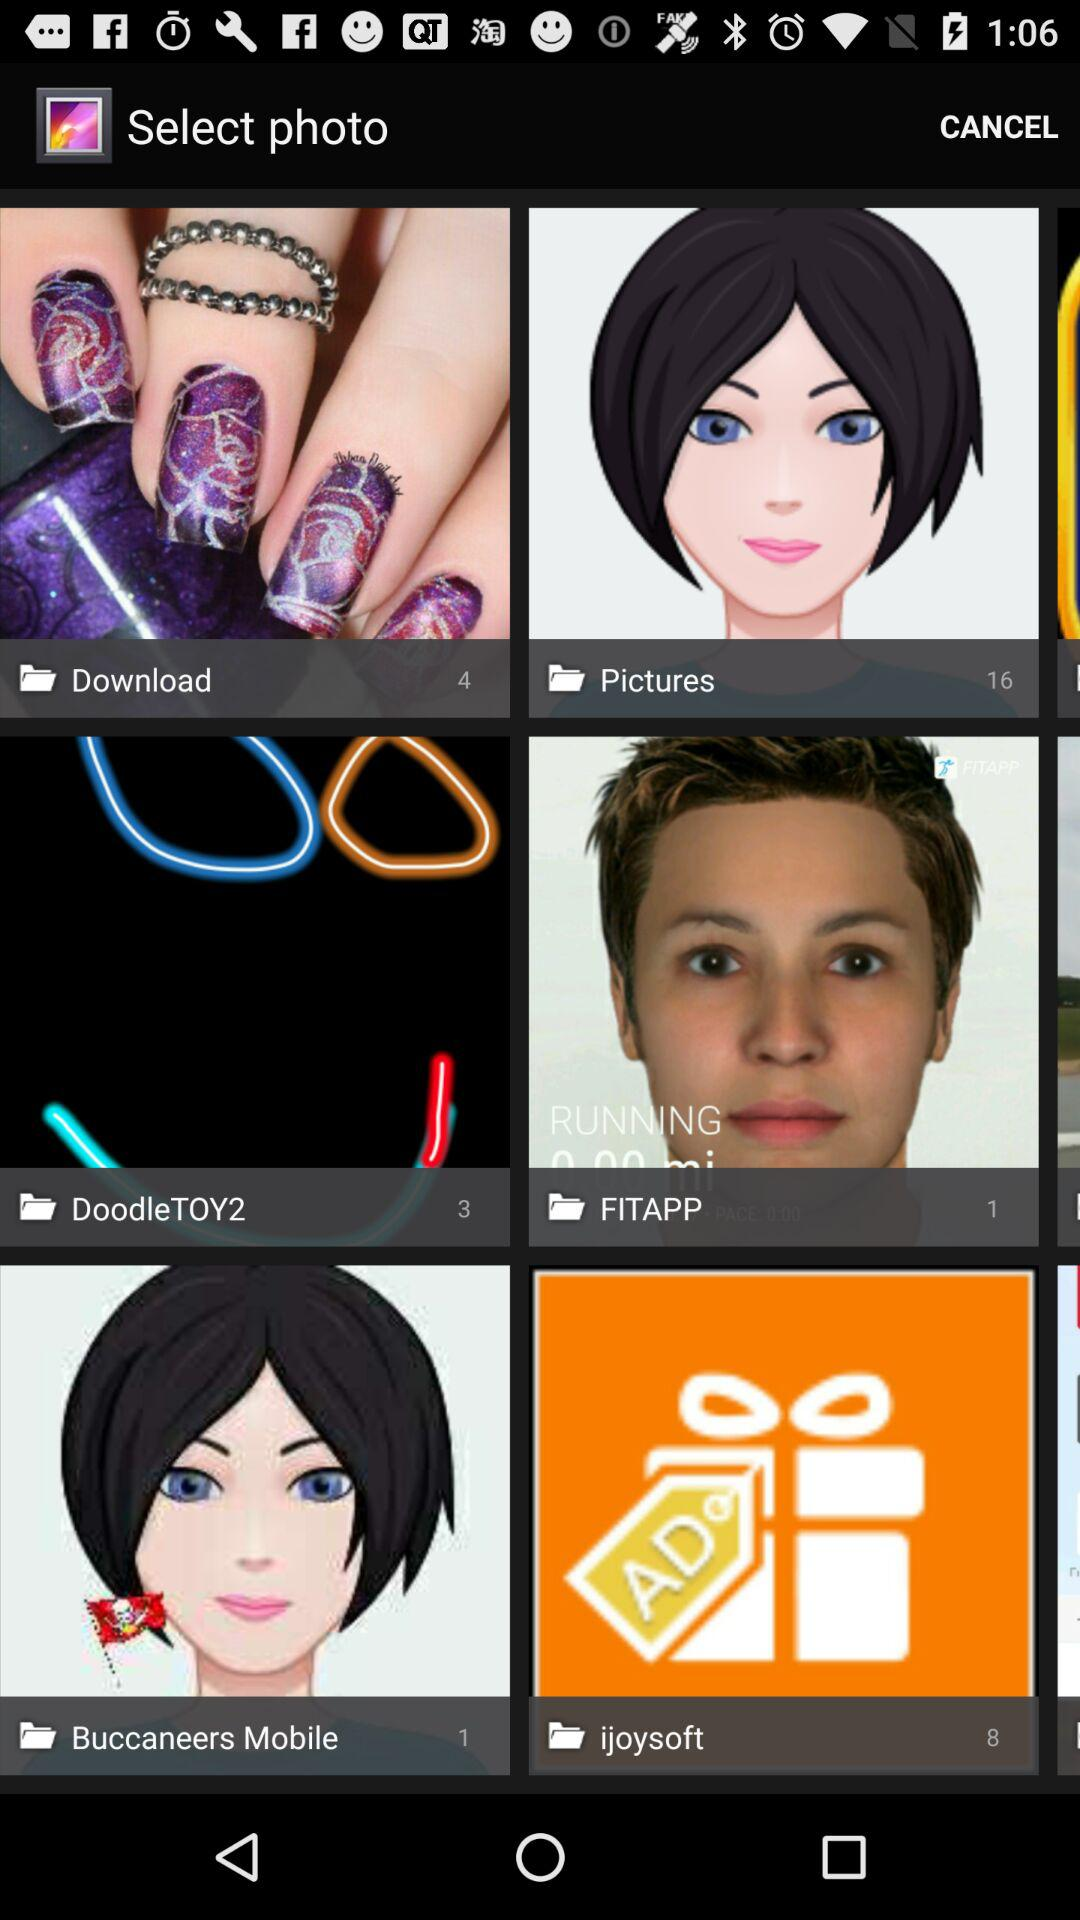How many pictures are available in the "Download" folder? There are 4 pictures in the "Download" folder. 